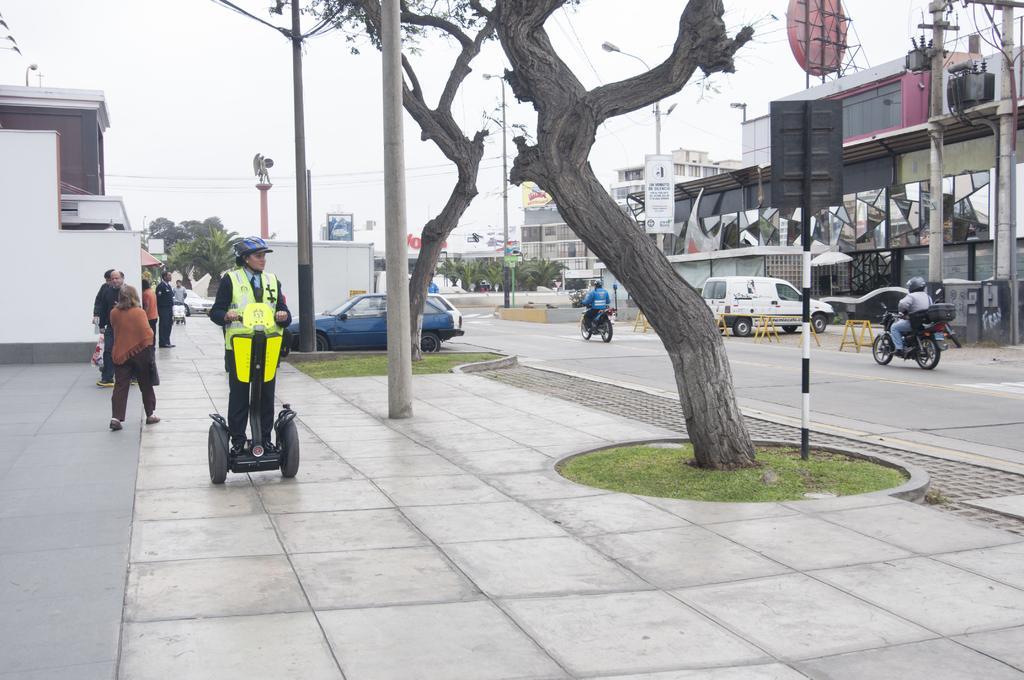Please provide a concise description of this image. In this image there is a road in the middle, on the road there are few vehicles, sign boards, poles, beside the road there are few buildings, on the road there are two persons riding on bi-cycle, on the left side there is a foot path on which there are poles, trees, vehicles, persons, at the top there is the sky. 